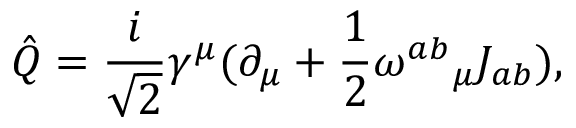Convert formula to latex. <formula><loc_0><loc_0><loc_500><loc_500>\hat { Q } = \frac { i } { \sqrt { 2 } } \gamma ^ { \mu } ( \partial _ { \mu } + \frac { 1 } { 2 } { \omega ^ { a b } } _ { \mu } J _ { a b } ) ,</formula> 